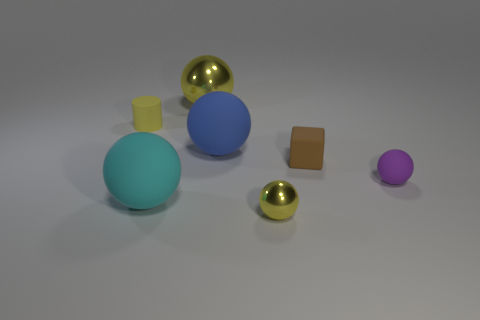Is the small metallic sphere the same color as the small cylinder?
Provide a succinct answer. Yes. Are there any yellow metal objects that have the same shape as the blue thing?
Keep it short and to the point. Yes. Does the cyan matte object have the same shape as the small rubber object that is in front of the brown rubber object?
Keep it short and to the point. Yes. There is a metal object that is in front of the tiny brown matte thing; what is its shape?
Your response must be concise. Sphere. What size is the sphere on the right side of the yellow metallic ball that is in front of the rubber cylinder?
Give a very brief answer. Small. Does the small cylinder have the same color as the small object in front of the small matte sphere?
Keep it short and to the point. Yes. What shape is the tiny yellow object that is on the left side of the tiny metallic thing that is in front of the purple sphere?
Make the answer very short. Cylinder. What is the material of the small object that is the same color as the tiny metal ball?
Offer a terse response. Rubber. Are there more yellow rubber objects than tiny gray metal cylinders?
Keep it short and to the point. Yes. What color is the tiny ball right of the yellow sphere that is in front of the yellow ball behind the small purple matte sphere?
Give a very brief answer. Purple. 